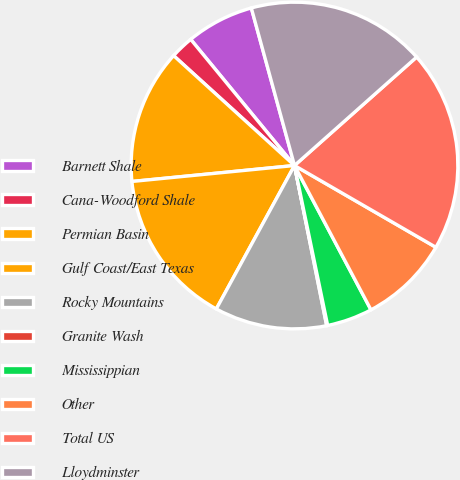Convert chart to OTSL. <chart><loc_0><loc_0><loc_500><loc_500><pie_chart><fcel>Barnett Shale<fcel>Cana-Woodford Shale<fcel>Permian Basin<fcel>Gulf Coast/East Texas<fcel>Rocky Mountains<fcel>Granite Wash<fcel>Mississippian<fcel>Other<fcel>Total US<fcel>Lloydminster<nl><fcel>6.7%<fcel>2.3%<fcel>13.3%<fcel>15.5%<fcel>11.1%<fcel>0.1%<fcel>4.5%<fcel>8.9%<fcel>19.9%<fcel>17.7%<nl></chart> 